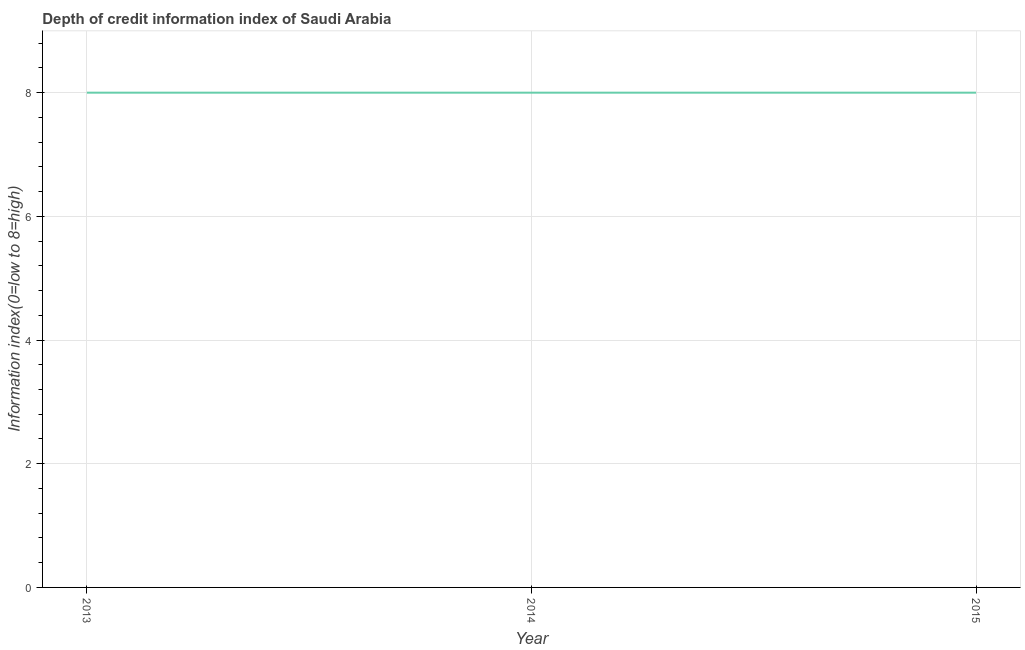What is the depth of credit information index in 2013?
Keep it short and to the point. 8. Across all years, what is the maximum depth of credit information index?
Your answer should be compact. 8. Across all years, what is the minimum depth of credit information index?
Give a very brief answer. 8. In which year was the depth of credit information index maximum?
Provide a short and direct response. 2013. In which year was the depth of credit information index minimum?
Make the answer very short. 2013. What is the sum of the depth of credit information index?
Provide a short and direct response. 24. What is the average depth of credit information index per year?
Your answer should be very brief. 8. Do a majority of the years between 2013 and 2015 (inclusive) have depth of credit information index greater than 6 ?
Keep it short and to the point. Yes. What is the ratio of the depth of credit information index in 2013 to that in 2015?
Ensure brevity in your answer.  1. Is the difference between the depth of credit information index in 2014 and 2015 greater than the difference between any two years?
Your response must be concise. Yes. What is the difference between the highest and the lowest depth of credit information index?
Ensure brevity in your answer.  0. Does the depth of credit information index monotonically increase over the years?
Make the answer very short. No. Are the values on the major ticks of Y-axis written in scientific E-notation?
Provide a short and direct response. No. Does the graph contain any zero values?
Your response must be concise. No. What is the title of the graph?
Make the answer very short. Depth of credit information index of Saudi Arabia. What is the label or title of the Y-axis?
Offer a very short reply. Information index(0=low to 8=high). What is the Information index(0=low to 8=high) of 2013?
Your answer should be very brief. 8. What is the Information index(0=low to 8=high) of 2015?
Make the answer very short. 8. What is the difference between the Information index(0=low to 8=high) in 2013 and 2014?
Ensure brevity in your answer.  0. What is the ratio of the Information index(0=low to 8=high) in 2013 to that in 2014?
Ensure brevity in your answer.  1. What is the ratio of the Information index(0=low to 8=high) in 2014 to that in 2015?
Provide a succinct answer. 1. 